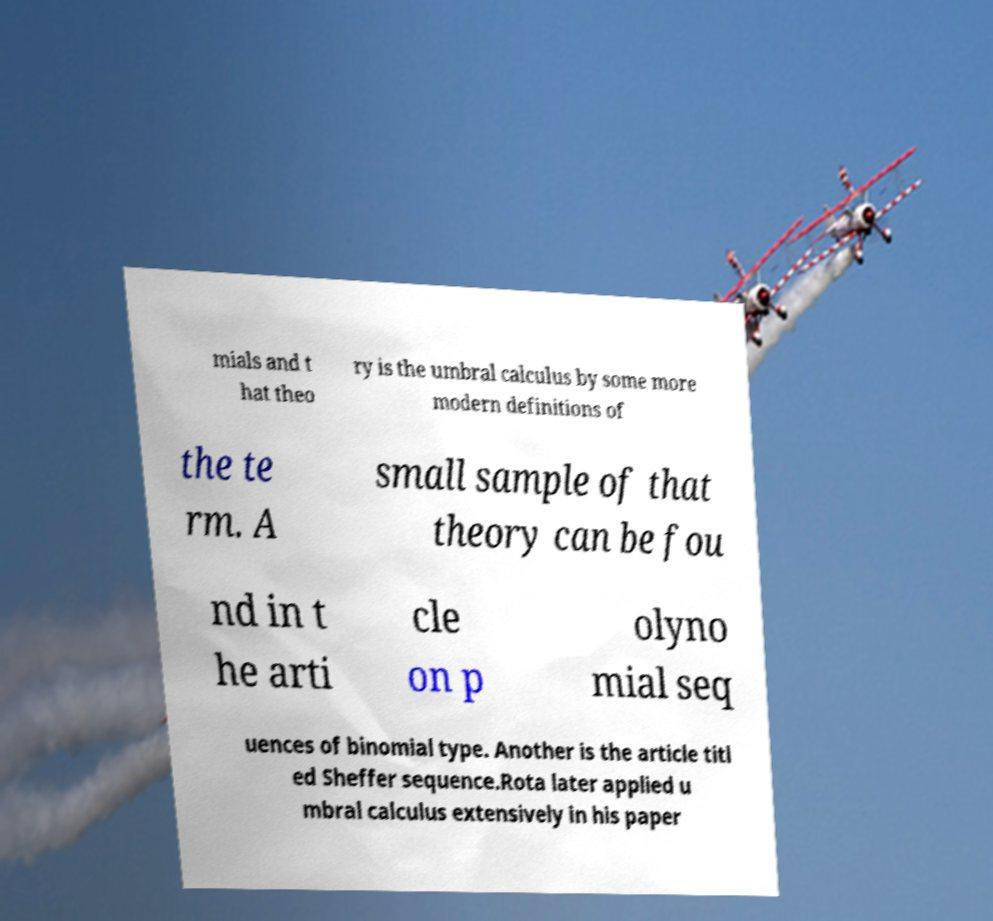There's text embedded in this image that I need extracted. Can you transcribe it verbatim? mials and t hat theo ry is the umbral calculus by some more modern definitions of the te rm. A small sample of that theory can be fou nd in t he arti cle on p olyno mial seq uences of binomial type. Another is the article titl ed Sheffer sequence.Rota later applied u mbral calculus extensively in his paper 